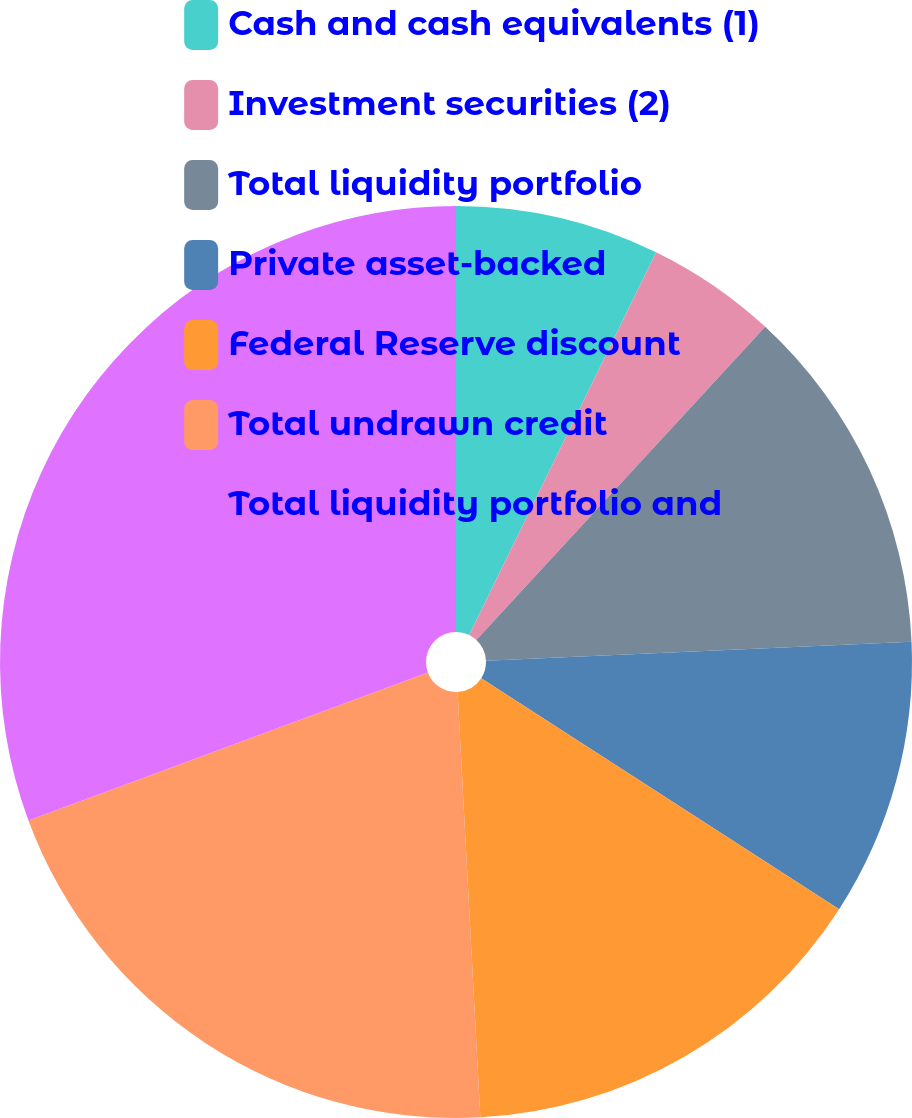<chart> <loc_0><loc_0><loc_500><loc_500><pie_chart><fcel>Cash and cash equivalents (1)<fcel>Investment securities (2)<fcel>Total liquidity portfolio<fcel>Private asset-backed<fcel>Federal Reserve discount<fcel>Total undrawn credit<fcel>Total liquidity portfolio and<nl><fcel>7.23%<fcel>4.63%<fcel>12.43%<fcel>9.83%<fcel>15.03%<fcel>20.2%<fcel>30.65%<nl></chart> 